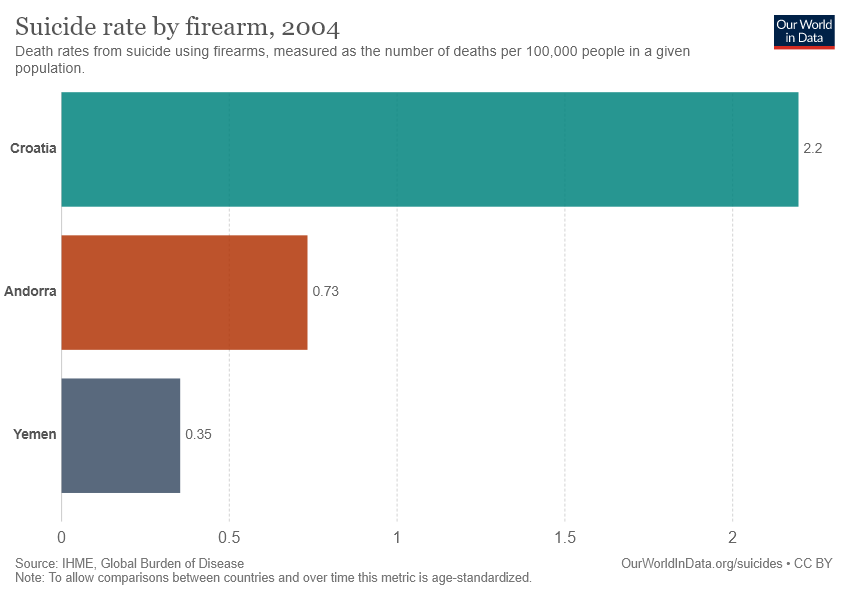Draw attention to some important aspects in this diagram. It is not the case that the average suicide rate in Yemen and Croatia is greater than 2. In other words, the average suicide rate in Yemen and Croatia is less than 2. According to recent data, the suicide rate in Andorra by firearms is 0.73 per 100,000 individuals. 